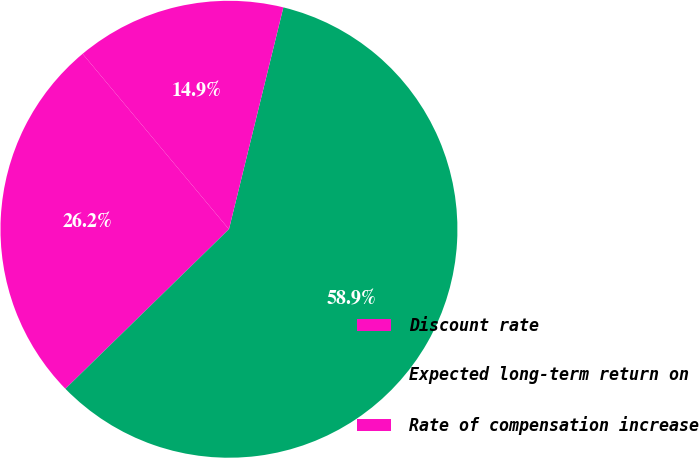<chart> <loc_0><loc_0><loc_500><loc_500><pie_chart><fcel>Discount rate<fcel>Expected long-term return on<fcel>Rate of compensation increase<nl><fcel>26.24%<fcel>58.87%<fcel>14.89%<nl></chart> 